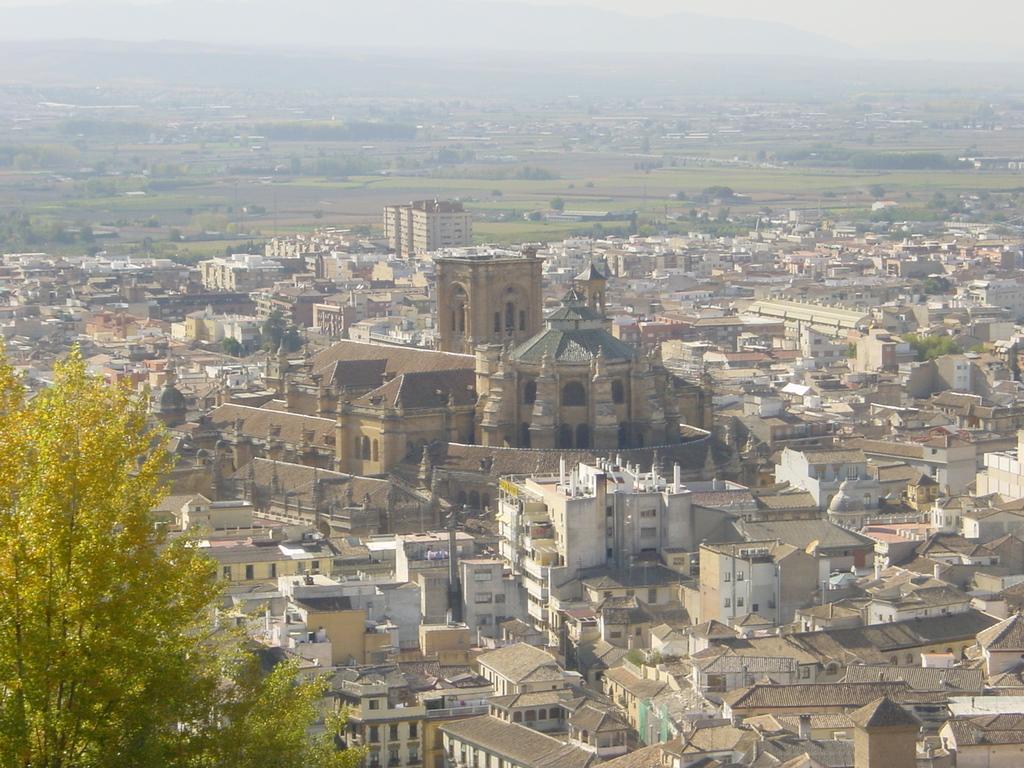How would you summarize this image in a sentence or two? In this image we can see many trees and plants. There are many houses and buildings in the image. We can see the sky in the image. There is a grassy land in the image. 